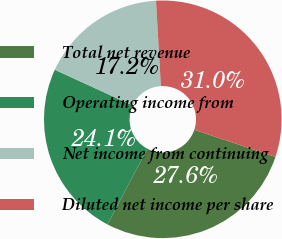<chart> <loc_0><loc_0><loc_500><loc_500><pie_chart><fcel>Total net revenue<fcel>Operating income from<fcel>Net income from continuing<fcel>Diluted net income per share<nl><fcel>27.59%<fcel>24.14%<fcel>17.24%<fcel>31.03%<nl></chart> 